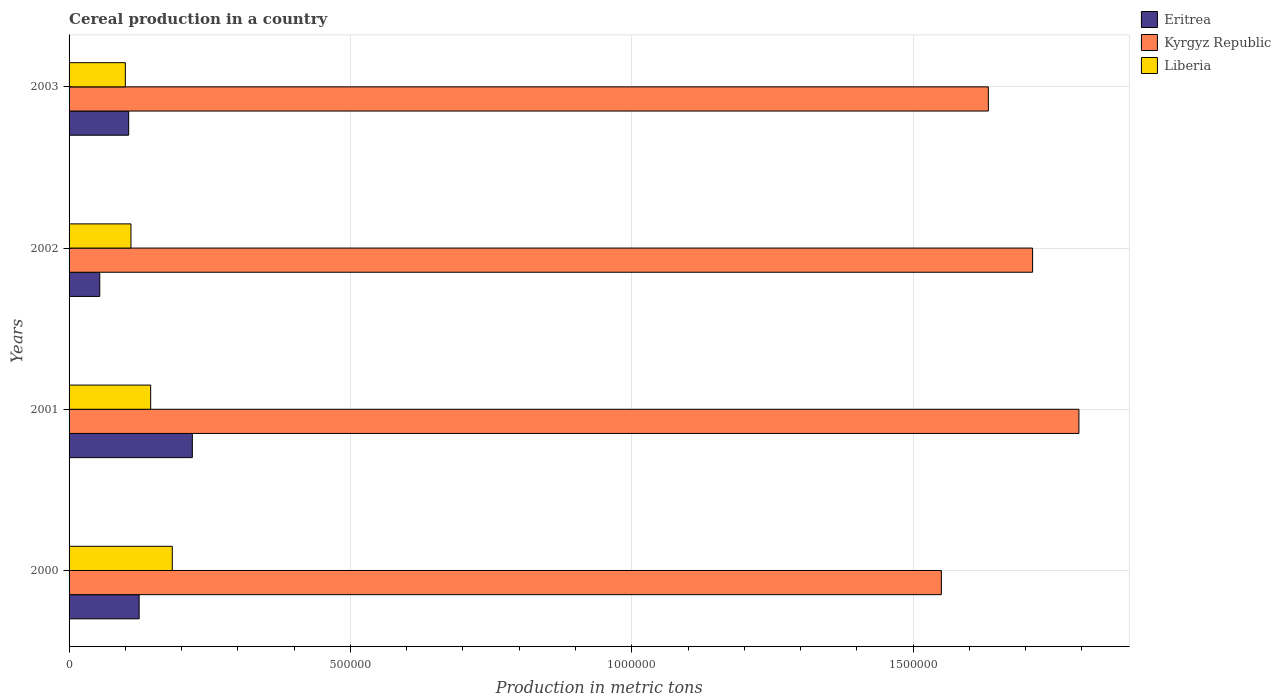How many different coloured bars are there?
Your response must be concise. 3. Are the number of bars on each tick of the Y-axis equal?
Offer a terse response. Yes. How many bars are there on the 4th tick from the bottom?
Provide a short and direct response. 3. In how many cases, is the number of bars for a given year not equal to the number of legend labels?
Offer a terse response. 0. What is the total cereal production in Liberia in 2003?
Your response must be concise. 1.00e+05. Across all years, what is the maximum total cereal production in Liberia?
Offer a terse response. 1.83e+05. Across all years, what is the minimum total cereal production in Kyrgyz Republic?
Give a very brief answer. 1.55e+06. What is the total total cereal production in Eritrea in the graph?
Give a very brief answer. 5.04e+05. What is the difference between the total cereal production in Kyrgyz Republic in 2000 and that in 2002?
Keep it short and to the point. -1.62e+05. What is the difference between the total cereal production in Eritrea in 2000 and the total cereal production in Kyrgyz Republic in 2001?
Your response must be concise. -1.67e+06. What is the average total cereal production in Kyrgyz Republic per year?
Provide a short and direct response. 1.67e+06. In the year 2001, what is the difference between the total cereal production in Kyrgyz Republic and total cereal production in Liberia?
Your response must be concise. 1.65e+06. In how many years, is the total cereal production in Eritrea greater than 600000 metric tons?
Keep it short and to the point. 0. What is the ratio of the total cereal production in Eritrea in 2000 to that in 2002?
Offer a very short reply. 2.28. Is the difference between the total cereal production in Kyrgyz Republic in 2001 and 2002 greater than the difference between the total cereal production in Liberia in 2001 and 2002?
Your response must be concise. Yes. What is the difference between the highest and the second highest total cereal production in Kyrgyz Republic?
Offer a terse response. 8.23e+04. What is the difference between the highest and the lowest total cereal production in Liberia?
Make the answer very short. 8.34e+04. Is the sum of the total cereal production in Eritrea in 2001 and 2002 greater than the maximum total cereal production in Liberia across all years?
Offer a very short reply. Yes. What does the 2nd bar from the top in 2001 represents?
Give a very brief answer. Kyrgyz Republic. What does the 3rd bar from the bottom in 2003 represents?
Keep it short and to the point. Liberia. How many bars are there?
Keep it short and to the point. 12. Are all the bars in the graph horizontal?
Provide a succinct answer. Yes. Does the graph contain any zero values?
Your answer should be compact. No. Does the graph contain grids?
Give a very brief answer. Yes. How are the legend labels stacked?
Keep it short and to the point. Vertical. What is the title of the graph?
Ensure brevity in your answer.  Cereal production in a country. Does "Nigeria" appear as one of the legend labels in the graph?
Your response must be concise. No. What is the label or title of the X-axis?
Make the answer very short. Production in metric tons. What is the Production in metric tons in Eritrea in 2000?
Your response must be concise. 1.25e+05. What is the Production in metric tons in Kyrgyz Republic in 2000?
Your answer should be very brief. 1.55e+06. What is the Production in metric tons of Liberia in 2000?
Offer a very short reply. 1.83e+05. What is the Production in metric tons of Eritrea in 2001?
Your response must be concise. 2.19e+05. What is the Production in metric tons of Kyrgyz Republic in 2001?
Give a very brief answer. 1.79e+06. What is the Production in metric tons in Liberia in 2001?
Ensure brevity in your answer.  1.45e+05. What is the Production in metric tons of Eritrea in 2002?
Give a very brief answer. 5.45e+04. What is the Production in metric tons in Kyrgyz Republic in 2002?
Offer a very short reply. 1.71e+06. What is the Production in metric tons of Liberia in 2002?
Offer a terse response. 1.10e+05. What is the Production in metric tons in Eritrea in 2003?
Give a very brief answer. 1.06e+05. What is the Production in metric tons of Kyrgyz Republic in 2003?
Give a very brief answer. 1.63e+06. Across all years, what is the maximum Production in metric tons of Eritrea?
Give a very brief answer. 2.19e+05. Across all years, what is the maximum Production in metric tons of Kyrgyz Republic?
Your response must be concise. 1.79e+06. Across all years, what is the maximum Production in metric tons in Liberia?
Give a very brief answer. 1.83e+05. Across all years, what is the minimum Production in metric tons of Eritrea?
Give a very brief answer. 5.45e+04. Across all years, what is the minimum Production in metric tons of Kyrgyz Republic?
Ensure brevity in your answer.  1.55e+06. What is the total Production in metric tons of Eritrea in the graph?
Make the answer very short. 5.04e+05. What is the total Production in metric tons of Kyrgyz Republic in the graph?
Give a very brief answer. 6.69e+06. What is the total Production in metric tons of Liberia in the graph?
Give a very brief answer. 5.38e+05. What is the difference between the Production in metric tons of Eritrea in 2000 and that in 2001?
Provide a succinct answer. -9.45e+04. What is the difference between the Production in metric tons of Kyrgyz Republic in 2000 and that in 2001?
Provide a short and direct response. -2.44e+05. What is the difference between the Production in metric tons of Liberia in 2000 and that in 2001?
Your answer should be compact. 3.84e+04. What is the difference between the Production in metric tons of Eritrea in 2000 and that in 2002?
Your response must be concise. 7.00e+04. What is the difference between the Production in metric tons of Kyrgyz Republic in 2000 and that in 2002?
Offer a terse response. -1.62e+05. What is the difference between the Production in metric tons in Liberia in 2000 and that in 2002?
Provide a short and direct response. 7.34e+04. What is the difference between the Production in metric tons in Eritrea in 2000 and that in 2003?
Keep it short and to the point. 1.86e+04. What is the difference between the Production in metric tons in Kyrgyz Republic in 2000 and that in 2003?
Provide a succinct answer. -8.35e+04. What is the difference between the Production in metric tons in Liberia in 2000 and that in 2003?
Your response must be concise. 8.34e+04. What is the difference between the Production in metric tons of Eritrea in 2001 and that in 2002?
Keep it short and to the point. 1.65e+05. What is the difference between the Production in metric tons in Kyrgyz Republic in 2001 and that in 2002?
Your answer should be compact. 8.23e+04. What is the difference between the Production in metric tons in Liberia in 2001 and that in 2002?
Provide a short and direct response. 3.50e+04. What is the difference between the Production in metric tons in Eritrea in 2001 and that in 2003?
Provide a short and direct response. 1.13e+05. What is the difference between the Production in metric tons of Kyrgyz Republic in 2001 and that in 2003?
Your response must be concise. 1.61e+05. What is the difference between the Production in metric tons of Liberia in 2001 and that in 2003?
Your response must be concise. 4.50e+04. What is the difference between the Production in metric tons of Eritrea in 2002 and that in 2003?
Provide a succinct answer. -5.14e+04. What is the difference between the Production in metric tons in Kyrgyz Republic in 2002 and that in 2003?
Offer a terse response. 7.86e+04. What is the difference between the Production in metric tons in Liberia in 2002 and that in 2003?
Keep it short and to the point. 10000. What is the difference between the Production in metric tons in Eritrea in 2000 and the Production in metric tons in Kyrgyz Republic in 2001?
Provide a short and direct response. -1.67e+06. What is the difference between the Production in metric tons in Eritrea in 2000 and the Production in metric tons in Liberia in 2001?
Keep it short and to the point. -2.05e+04. What is the difference between the Production in metric tons of Kyrgyz Republic in 2000 and the Production in metric tons of Liberia in 2001?
Provide a short and direct response. 1.41e+06. What is the difference between the Production in metric tons in Eritrea in 2000 and the Production in metric tons in Kyrgyz Republic in 2002?
Your answer should be very brief. -1.59e+06. What is the difference between the Production in metric tons of Eritrea in 2000 and the Production in metric tons of Liberia in 2002?
Offer a terse response. 1.45e+04. What is the difference between the Production in metric tons in Kyrgyz Republic in 2000 and the Production in metric tons in Liberia in 2002?
Ensure brevity in your answer.  1.44e+06. What is the difference between the Production in metric tons in Eritrea in 2000 and the Production in metric tons in Kyrgyz Republic in 2003?
Ensure brevity in your answer.  -1.51e+06. What is the difference between the Production in metric tons of Eritrea in 2000 and the Production in metric tons of Liberia in 2003?
Your response must be concise. 2.45e+04. What is the difference between the Production in metric tons in Kyrgyz Republic in 2000 and the Production in metric tons in Liberia in 2003?
Give a very brief answer. 1.45e+06. What is the difference between the Production in metric tons in Eritrea in 2001 and the Production in metric tons in Kyrgyz Republic in 2002?
Provide a succinct answer. -1.49e+06. What is the difference between the Production in metric tons in Eritrea in 2001 and the Production in metric tons in Liberia in 2002?
Your response must be concise. 1.09e+05. What is the difference between the Production in metric tons in Kyrgyz Republic in 2001 and the Production in metric tons in Liberia in 2002?
Your answer should be very brief. 1.68e+06. What is the difference between the Production in metric tons in Eritrea in 2001 and the Production in metric tons in Kyrgyz Republic in 2003?
Ensure brevity in your answer.  -1.41e+06. What is the difference between the Production in metric tons in Eritrea in 2001 and the Production in metric tons in Liberia in 2003?
Your response must be concise. 1.19e+05. What is the difference between the Production in metric tons in Kyrgyz Republic in 2001 and the Production in metric tons in Liberia in 2003?
Provide a short and direct response. 1.69e+06. What is the difference between the Production in metric tons in Eritrea in 2002 and the Production in metric tons in Kyrgyz Republic in 2003?
Provide a short and direct response. -1.58e+06. What is the difference between the Production in metric tons of Eritrea in 2002 and the Production in metric tons of Liberia in 2003?
Your response must be concise. -4.55e+04. What is the difference between the Production in metric tons of Kyrgyz Republic in 2002 and the Production in metric tons of Liberia in 2003?
Provide a succinct answer. 1.61e+06. What is the average Production in metric tons in Eritrea per year?
Ensure brevity in your answer.  1.26e+05. What is the average Production in metric tons in Kyrgyz Republic per year?
Provide a short and direct response. 1.67e+06. What is the average Production in metric tons of Liberia per year?
Provide a succinct answer. 1.35e+05. In the year 2000, what is the difference between the Production in metric tons in Eritrea and Production in metric tons in Kyrgyz Republic?
Offer a very short reply. -1.43e+06. In the year 2000, what is the difference between the Production in metric tons in Eritrea and Production in metric tons in Liberia?
Offer a terse response. -5.89e+04. In the year 2000, what is the difference between the Production in metric tons in Kyrgyz Republic and Production in metric tons in Liberia?
Provide a succinct answer. 1.37e+06. In the year 2001, what is the difference between the Production in metric tons in Eritrea and Production in metric tons in Kyrgyz Republic?
Your response must be concise. -1.58e+06. In the year 2001, what is the difference between the Production in metric tons in Eritrea and Production in metric tons in Liberia?
Give a very brief answer. 7.41e+04. In the year 2001, what is the difference between the Production in metric tons of Kyrgyz Republic and Production in metric tons of Liberia?
Offer a terse response. 1.65e+06. In the year 2002, what is the difference between the Production in metric tons of Eritrea and Production in metric tons of Kyrgyz Republic?
Offer a terse response. -1.66e+06. In the year 2002, what is the difference between the Production in metric tons in Eritrea and Production in metric tons in Liberia?
Provide a succinct answer. -5.55e+04. In the year 2002, what is the difference between the Production in metric tons in Kyrgyz Republic and Production in metric tons in Liberia?
Offer a terse response. 1.60e+06. In the year 2003, what is the difference between the Production in metric tons in Eritrea and Production in metric tons in Kyrgyz Republic?
Provide a short and direct response. -1.53e+06. In the year 2003, what is the difference between the Production in metric tons of Eritrea and Production in metric tons of Liberia?
Your answer should be compact. 5944. In the year 2003, what is the difference between the Production in metric tons in Kyrgyz Republic and Production in metric tons in Liberia?
Provide a succinct answer. 1.53e+06. What is the ratio of the Production in metric tons in Eritrea in 2000 to that in 2001?
Your answer should be very brief. 0.57. What is the ratio of the Production in metric tons of Kyrgyz Republic in 2000 to that in 2001?
Ensure brevity in your answer.  0.86. What is the ratio of the Production in metric tons of Liberia in 2000 to that in 2001?
Give a very brief answer. 1.26. What is the ratio of the Production in metric tons in Eritrea in 2000 to that in 2002?
Make the answer very short. 2.28. What is the ratio of the Production in metric tons in Kyrgyz Republic in 2000 to that in 2002?
Ensure brevity in your answer.  0.91. What is the ratio of the Production in metric tons of Liberia in 2000 to that in 2002?
Ensure brevity in your answer.  1.67. What is the ratio of the Production in metric tons in Eritrea in 2000 to that in 2003?
Offer a terse response. 1.18. What is the ratio of the Production in metric tons of Kyrgyz Republic in 2000 to that in 2003?
Make the answer very short. 0.95. What is the ratio of the Production in metric tons of Liberia in 2000 to that in 2003?
Your response must be concise. 1.83. What is the ratio of the Production in metric tons of Eritrea in 2001 to that in 2002?
Offer a very short reply. 4.02. What is the ratio of the Production in metric tons in Kyrgyz Republic in 2001 to that in 2002?
Offer a very short reply. 1.05. What is the ratio of the Production in metric tons of Liberia in 2001 to that in 2002?
Give a very brief answer. 1.32. What is the ratio of the Production in metric tons in Eritrea in 2001 to that in 2003?
Offer a very short reply. 2.07. What is the ratio of the Production in metric tons in Kyrgyz Republic in 2001 to that in 2003?
Your answer should be very brief. 1.1. What is the ratio of the Production in metric tons in Liberia in 2001 to that in 2003?
Make the answer very short. 1.45. What is the ratio of the Production in metric tons in Eritrea in 2002 to that in 2003?
Give a very brief answer. 0.51. What is the ratio of the Production in metric tons in Kyrgyz Republic in 2002 to that in 2003?
Give a very brief answer. 1.05. What is the ratio of the Production in metric tons of Liberia in 2002 to that in 2003?
Your answer should be very brief. 1.1. What is the difference between the highest and the second highest Production in metric tons in Eritrea?
Give a very brief answer. 9.45e+04. What is the difference between the highest and the second highest Production in metric tons in Kyrgyz Republic?
Provide a succinct answer. 8.23e+04. What is the difference between the highest and the second highest Production in metric tons of Liberia?
Provide a short and direct response. 3.84e+04. What is the difference between the highest and the lowest Production in metric tons in Eritrea?
Make the answer very short. 1.65e+05. What is the difference between the highest and the lowest Production in metric tons in Kyrgyz Republic?
Offer a very short reply. 2.44e+05. What is the difference between the highest and the lowest Production in metric tons of Liberia?
Your response must be concise. 8.34e+04. 